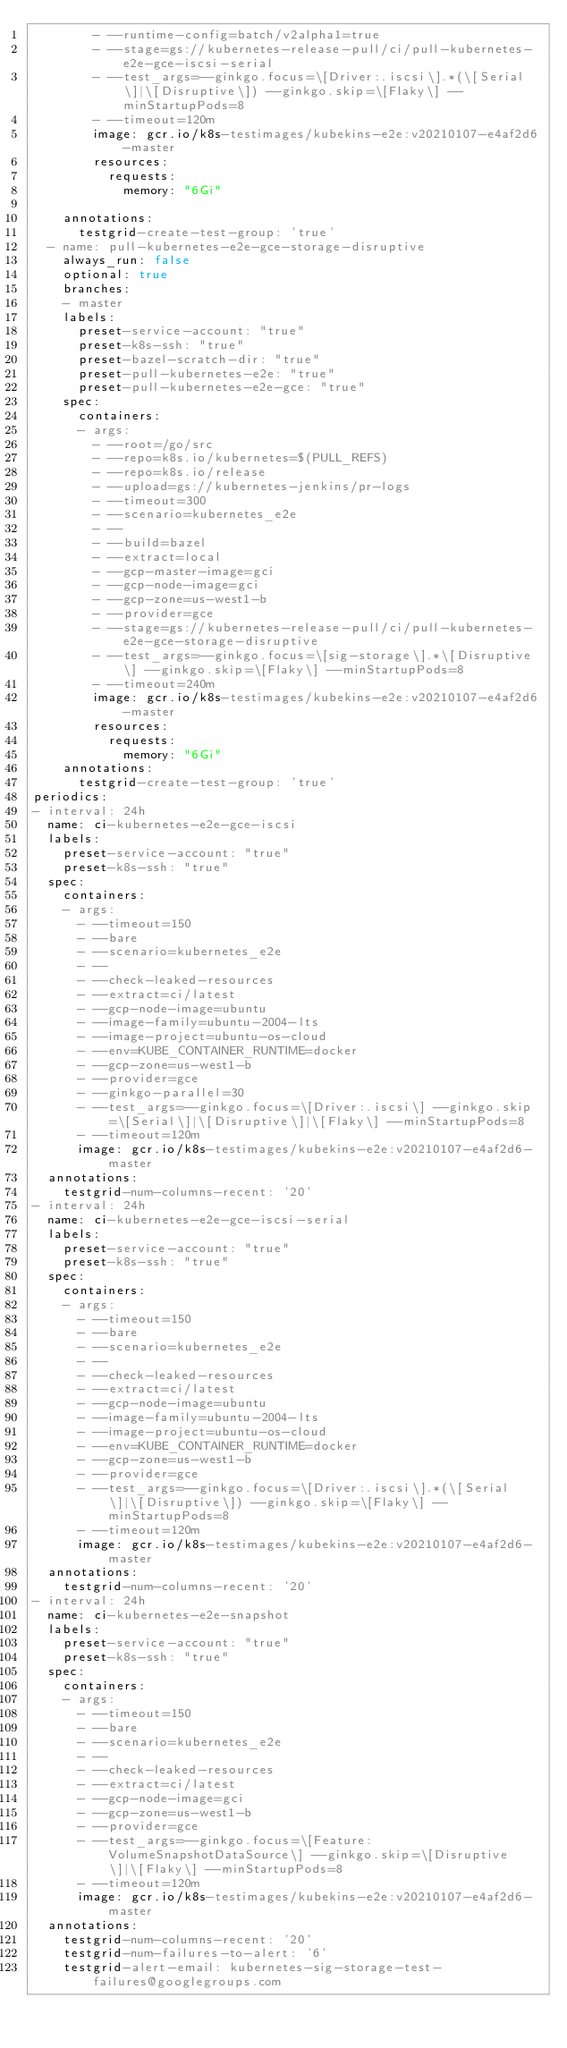Convert code to text. <code><loc_0><loc_0><loc_500><loc_500><_YAML_>        - --runtime-config=batch/v2alpha1=true
        - --stage=gs://kubernetes-release-pull/ci/pull-kubernetes-e2e-gce-iscsi-serial
        - --test_args=--ginkgo.focus=\[Driver:.iscsi\].*(\[Serial\]|\[Disruptive\]) --ginkgo.skip=\[Flaky\] --minStartupPods=8
        - --timeout=120m
        image: gcr.io/k8s-testimages/kubekins-e2e:v20210107-e4af2d6-master
        resources:
          requests:
            memory: "6Gi"

    annotations:
      testgrid-create-test-group: 'true'
  - name: pull-kubernetes-e2e-gce-storage-disruptive
    always_run: false
    optional: true
    branches:
    - master
    labels:
      preset-service-account: "true"
      preset-k8s-ssh: "true"
      preset-bazel-scratch-dir: "true"
      preset-pull-kubernetes-e2e: "true"
      preset-pull-kubernetes-e2e-gce: "true"
    spec:
      containers:
      - args:
        - --root=/go/src
        - --repo=k8s.io/kubernetes=$(PULL_REFS)
        - --repo=k8s.io/release
        - --upload=gs://kubernetes-jenkins/pr-logs
        - --timeout=300
        - --scenario=kubernetes_e2e
        - --
        - --build=bazel
        - --extract=local
        - --gcp-master-image=gci
        - --gcp-node-image=gci
        - --gcp-zone=us-west1-b
        - --provider=gce
        - --stage=gs://kubernetes-release-pull/ci/pull-kubernetes-e2e-gce-storage-disruptive
        - --test_args=--ginkgo.focus=\[sig-storage\].*\[Disruptive\] --ginkgo.skip=\[Flaky\] --minStartupPods=8
        - --timeout=240m
        image: gcr.io/k8s-testimages/kubekins-e2e:v20210107-e4af2d6-master
        resources:
          requests:
            memory: "6Gi"
    annotations:
      testgrid-create-test-group: 'true'
periodics:
- interval: 24h
  name: ci-kubernetes-e2e-gce-iscsi
  labels:
    preset-service-account: "true"
    preset-k8s-ssh: "true"
  spec:
    containers:
    - args:
      - --timeout=150
      - --bare
      - --scenario=kubernetes_e2e
      - --
      - --check-leaked-resources
      - --extract=ci/latest
      - --gcp-node-image=ubuntu
      - --image-family=ubuntu-2004-lts
      - --image-project=ubuntu-os-cloud
      - --env=KUBE_CONTAINER_RUNTIME=docker
      - --gcp-zone=us-west1-b
      - --provider=gce
      - --ginkgo-parallel=30
      - --test_args=--ginkgo.focus=\[Driver:.iscsi\] --ginkgo.skip=\[Serial\]|\[Disruptive\]|\[Flaky\] --minStartupPods=8
      - --timeout=120m
      image: gcr.io/k8s-testimages/kubekins-e2e:v20210107-e4af2d6-master
  annotations:
    testgrid-num-columns-recent: '20'
- interval: 24h
  name: ci-kubernetes-e2e-gce-iscsi-serial
  labels:
    preset-service-account: "true"
    preset-k8s-ssh: "true"
  spec:
    containers:
    - args:
      - --timeout=150
      - --bare
      - --scenario=kubernetes_e2e
      - --
      - --check-leaked-resources
      - --extract=ci/latest
      - --gcp-node-image=ubuntu
      - --image-family=ubuntu-2004-lts
      - --image-project=ubuntu-os-cloud
      - --env=KUBE_CONTAINER_RUNTIME=docker
      - --gcp-zone=us-west1-b
      - --provider=gce
      - --test_args=--ginkgo.focus=\[Driver:.iscsi\].*(\[Serial\]|\[Disruptive\]) --ginkgo.skip=\[Flaky\] --minStartupPods=8
      - --timeout=120m
      image: gcr.io/k8s-testimages/kubekins-e2e:v20210107-e4af2d6-master
  annotations:
    testgrid-num-columns-recent: '20'
- interval: 24h
  name: ci-kubernetes-e2e-snapshot
  labels:
    preset-service-account: "true"
    preset-k8s-ssh: "true"
  spec:
    containers:
    - args:
      - --timeout=150
      - --bare
      - --scenario=kubernetes_e2e
      - --
      - --check-leaked-resources
      - --extract=ci/latest
      - --gcp-node-image=gci
      - --gcp-zone=us-west1-b
      - --provider=gce
      - --test_args=--ginkgo.focus=\[Feature:VolumeSnapshotDataSource\] --ginkgo.skip=\[Disruptive\]|\[Flaky\] --minStartupPods=8
      - --timeout=120m
      image: gcr.io/k8s-testimages/kubekins-e2e:v20210107-e4af2d6-master
  annotations:
    testgrid-num-columns-recent: '20'
    testgrid-num-failures-to-alert: '6'
    testgrid-alert-email: kubernetes-sig-storage-test-failures@googlegroups.com
</code> 